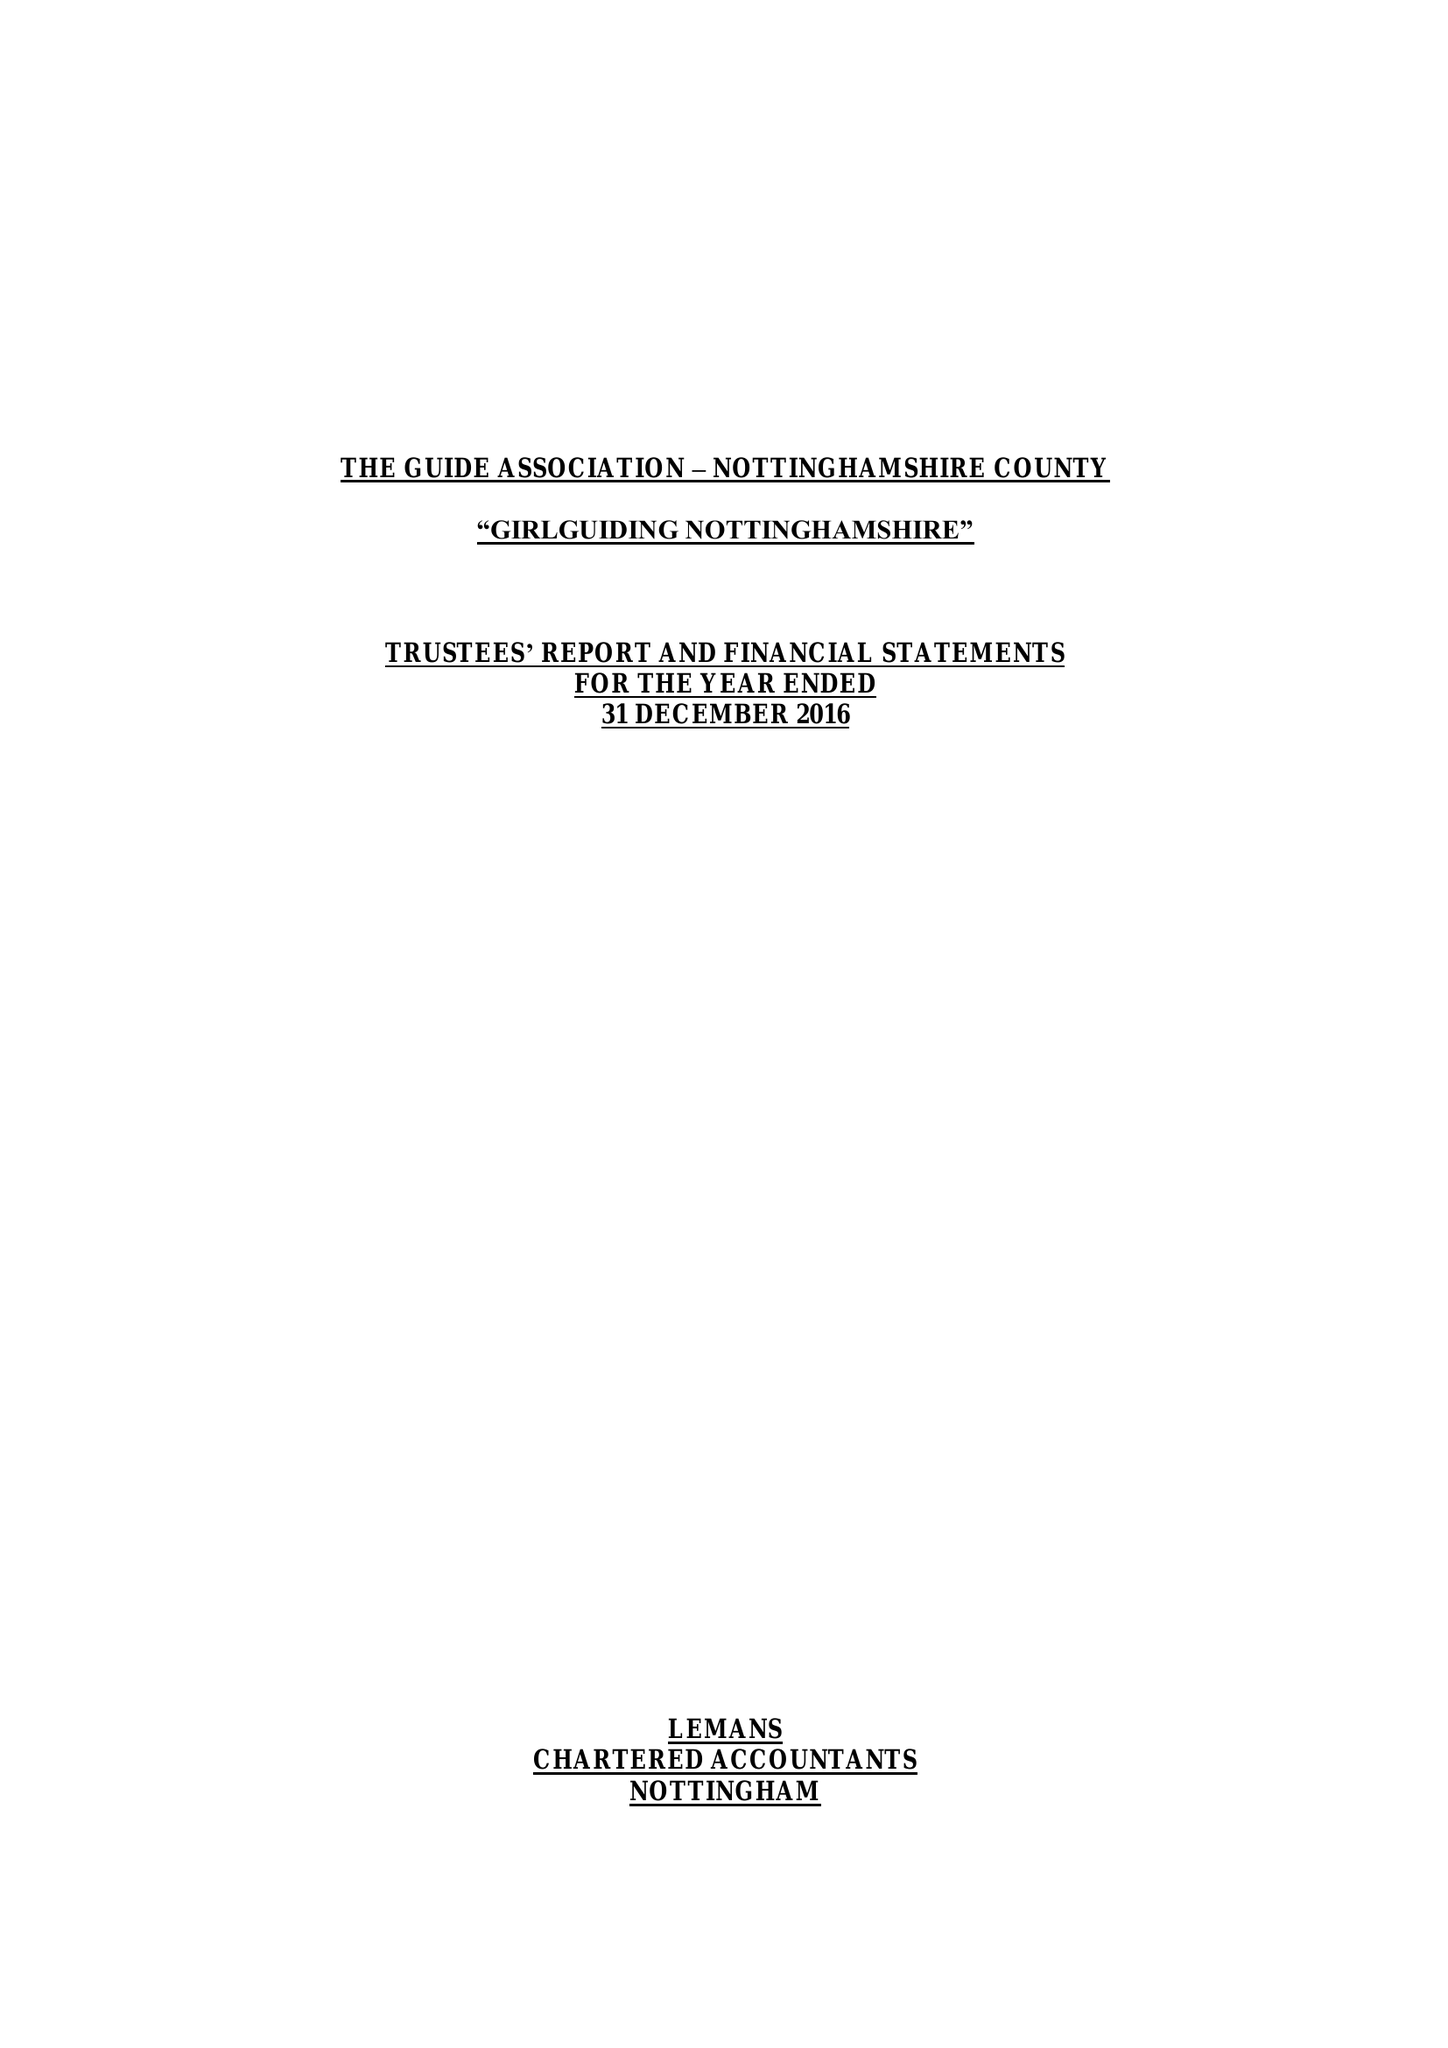What is the value for the charity_number?
Answer the question using a single word or phrase. 503168 